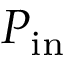<formula> <loc_0><loc_0><loc_500><loc_500>P _ { i n }</formula> 